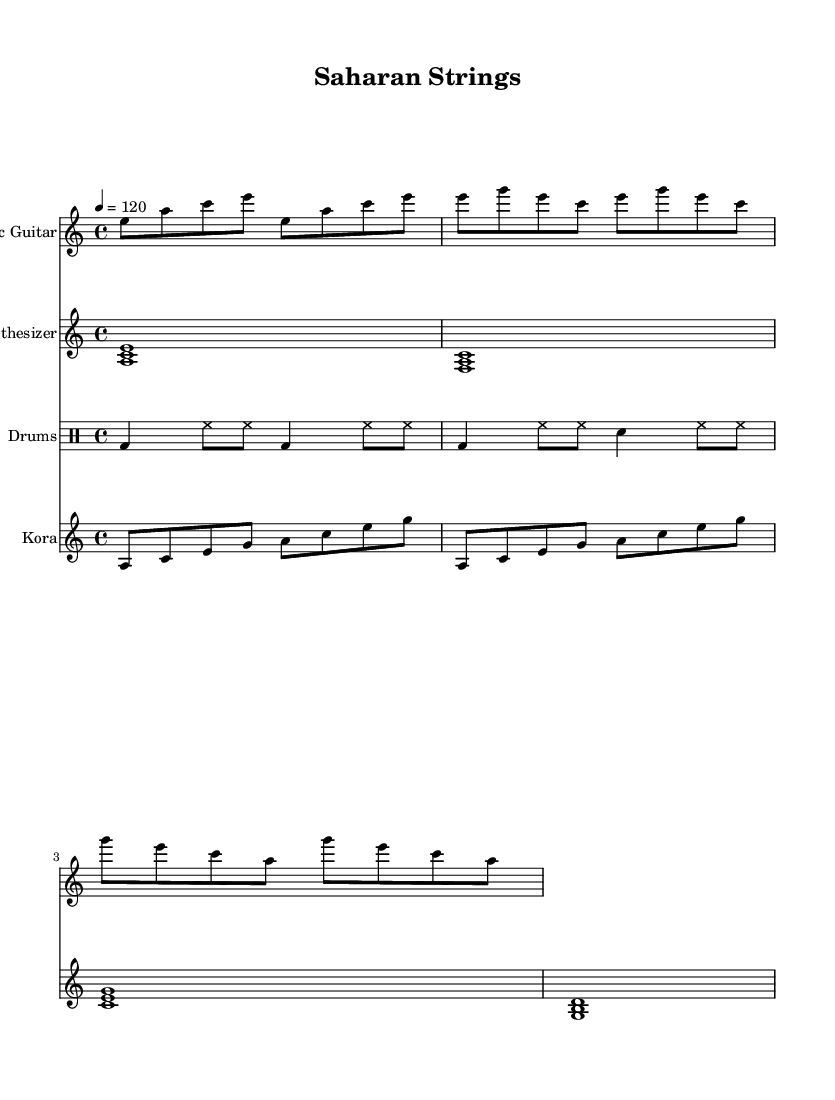What is the key signature of this music? The key signature indicated in the global section is A minor, which has no sharps or flats.
Answer: A minor What is the time signature of this piece? The time signature is shown in the global section and is 4/4, meaning there are four beats per measure.
Answer: 4/4 What is the tempo marking of the music? The tempo marking shows that the piece is to be played at a speed of 120 beats per minute.
Answer: 120 How many measures are in the electric guitar part? Counting the measures in the electric guitar's notation, there are a total of 7 measures.
Answer: 7 Which instruments are included in this score? The score explicitly lists Electric Guitar, Synthesizer, Drums, and Kora as the instruments.
Answer: Electric Guitar, Synthesizer, Drums, Kora What rhythmic pattern is primarily used in the drum section? The drum part utilizes a bass drum and hi-hat pattern combined with snare hits, showcasing an African rhythm influence.
Answer: Bass drum, hi-hat, snare How does the kora part interact with the guitar? The kora part complements the electric guitar by providing a melodic line that intertwines with the guitar chords, creating rich textures typical of world music.
Answer: Intertwining melodic line 